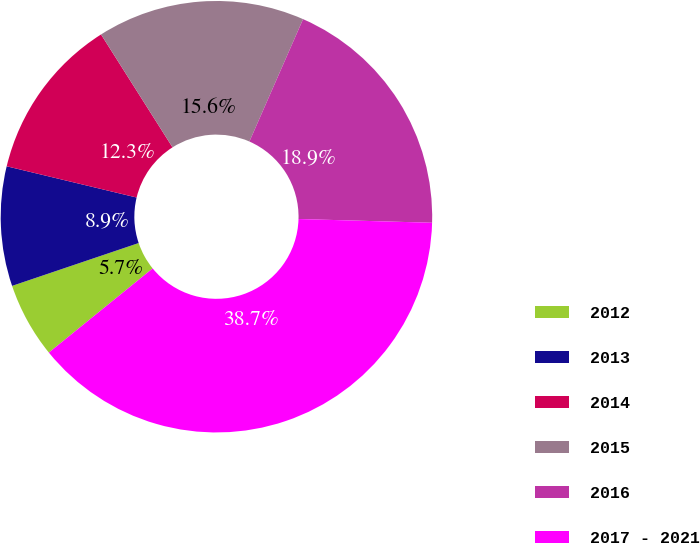Convert chart to OTSL. <chart><loc_0><loc_0><loc_500><loc_500><pie_chart><fcel>2012<fcel>2013<fcel>2014<fcel>2015<fcel>2016<fcel>2017 - 2021<nl><fcel>5.65%<fcel>8.95%<fcel>12.26%<fcel>15.56%<fcel>18.87%<fcel>38.71%<nl></chart> 